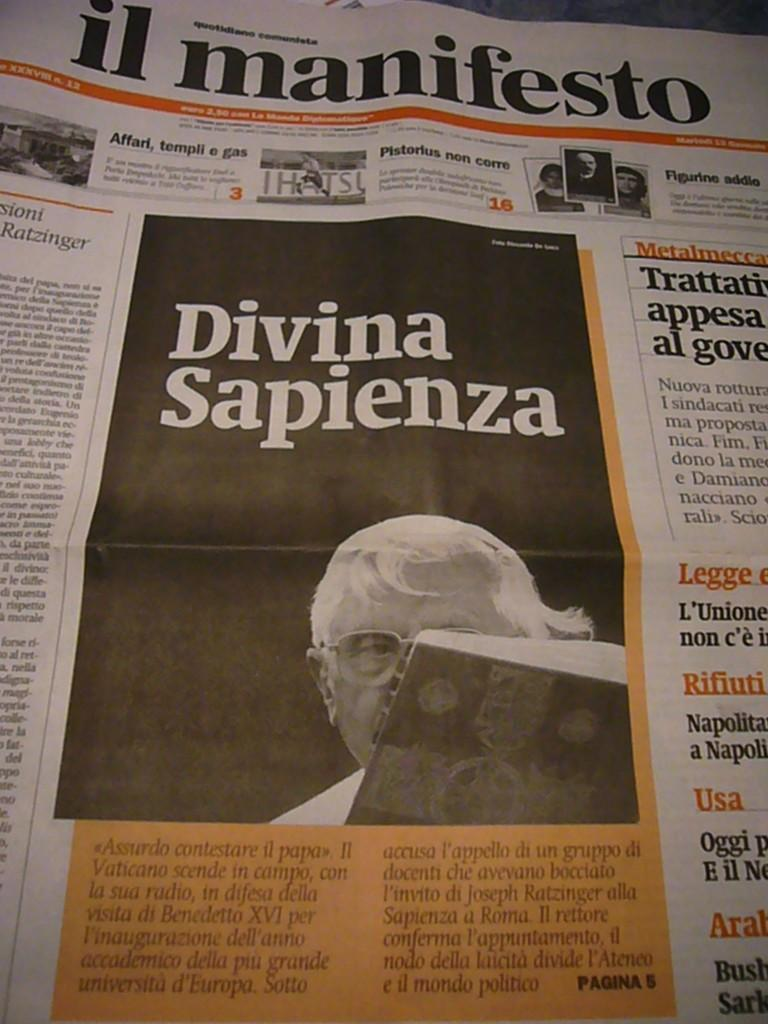What is the main object in the center of the image? There is a newspaper in the center of the image. What can be found on the newspaper? There is text written on the newspaper. How many cats are sitting on the newspaper in the image? There are no cats present in the image; it only features a newspaper with text. 